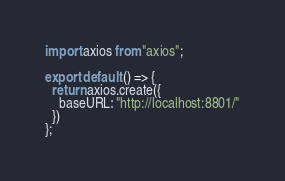Convert code to text. <code><loc_0><loc_0><loc_500><loc_500><_JavaScript_>import axios from "axios";

export default () => {
  return axios.create({
    baseURL: "http://localhost:8801/"
  })
};

</code> 